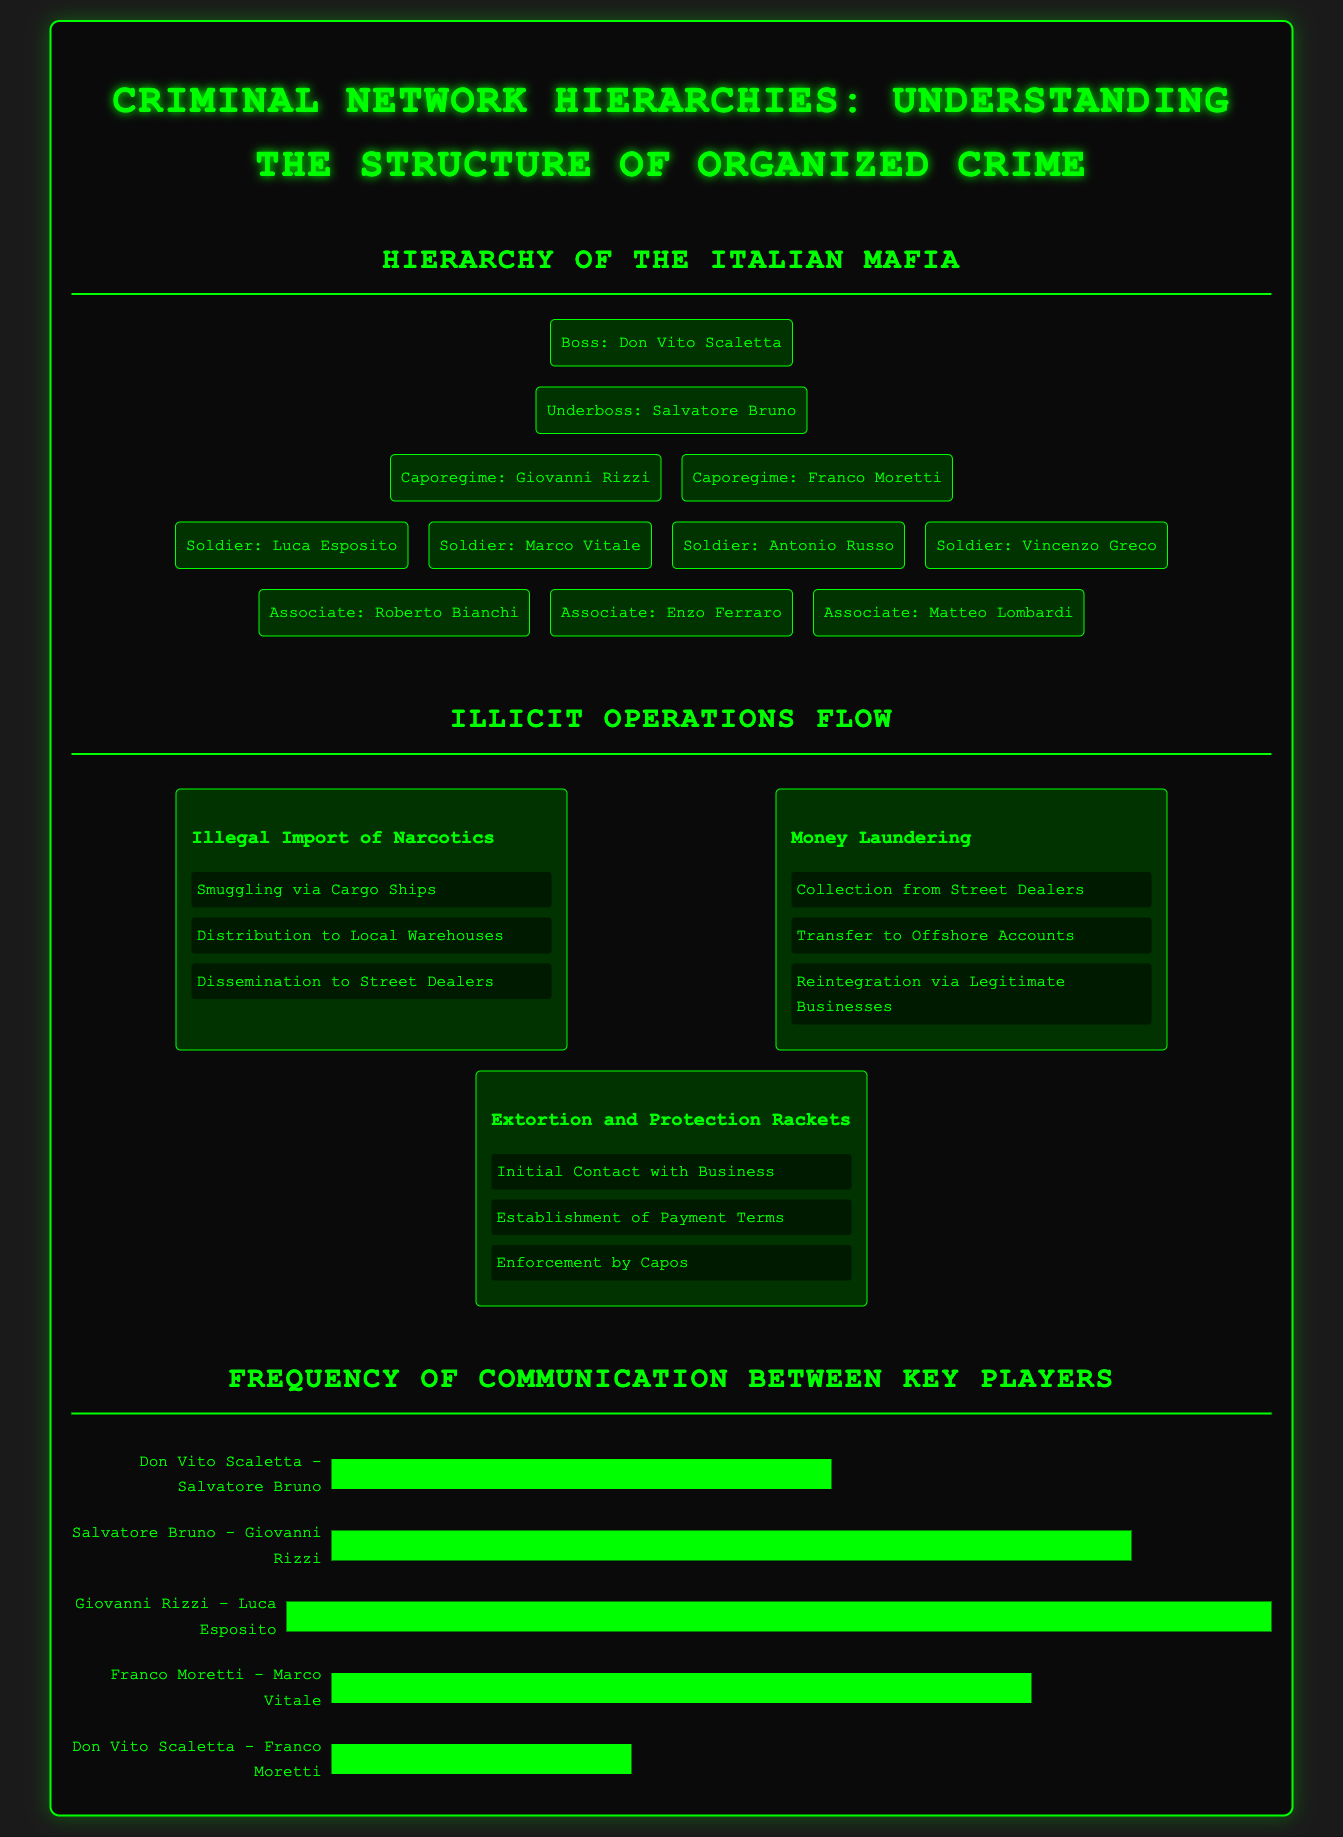What is the name of the Boss? The Boss of the Italian Mafia is identified as Don Vito Scaletta in the organizational chart.
Answer: Don Vito Scaletta Who is the Underboss? The Underboss listed in the document is Salvatore Bruno.
Answer: Salvatore Bruno How many Caporegime are mentioned? The document states there are two Caporegime: Giovanni Rizzi and Franco Moretti.
Answer: 2 What is the first step in illegal narcotics operations? The first step in the flow of illegal narcotics is Smuggling via Cargo Ships.
Answer: Smuggling via Cargo Ships What is the maximum frequency score used in the bar graph? The maximum frequency score indicated for communication measurement in the graph is 12.
Answer: 12 Which drug operation involves offshore accounts? The money laundering operation involves transferring money to offshore accounts.
Answer: Money Laundering Which Soldier is listed last in the hierarchy? The Soldier listed last in the hierarchy is Vincenzo Greco.
Answer: Vincenzo Greco What is the second step in extortion operations? The second step in extortion operations is Establishment of Payment Terms.
Answer: Establishment of Payment Terms How many Associates are in the document? The document specifies there are three Associates mentioned.
Answer: 3 Who has the highest frequency of communication in the bar graph? The communication with the highest frequency is between Giovanni Rizzi and Luca Esposito.
Answer: Giovanni Rizzi - Luca Esposito 